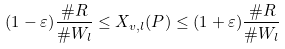Convert formula to latex. <formula><loc_0><loc_0><loc_500><loc_500>( 1 - \varepsilon ) \frac { \# R } { \# W _ { l } } \leq X _ { v , l } ( P ) \leq ( 1 + \varepsilon ) \frac { \# R } { \# W _ { l } }</formula> 